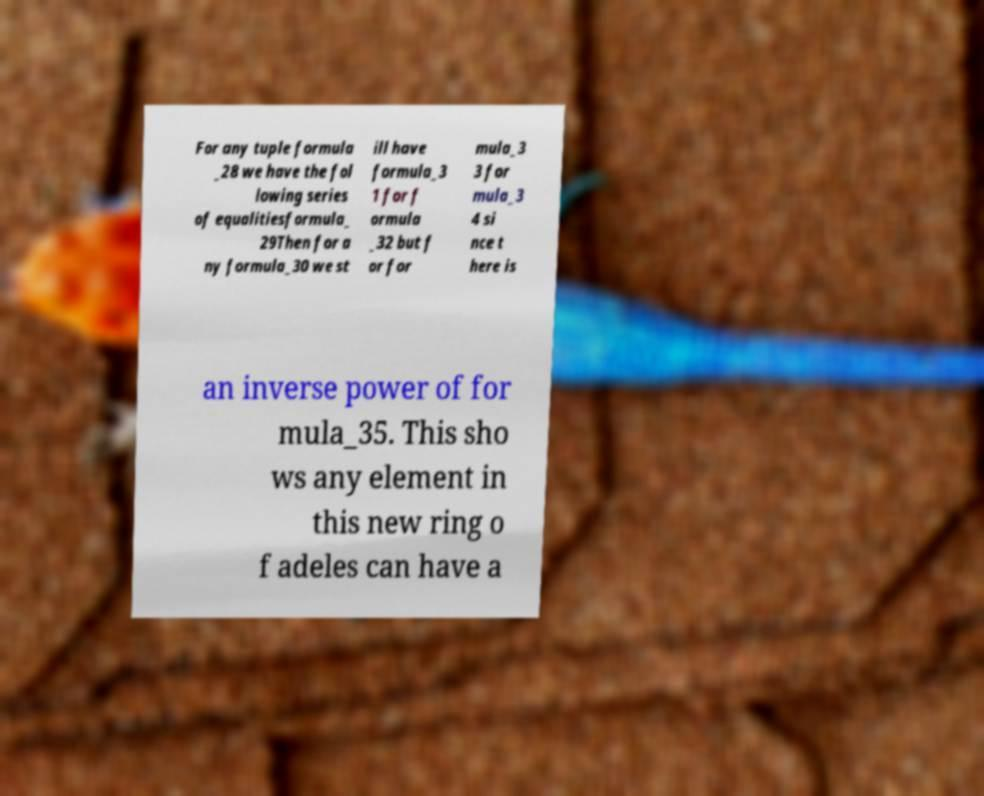For documentation purposes, I need the text within this image transcribed. Could you provide that? For any tuple formula _28 we have the fol lowing series of equalitiesformula_ 29Then for a ny formula_30 we st ill have formula_3 1 for f ormula _32 but f or for mula_3 3 for mula_3 4 si nce t here is an inverse power of for mula_35. This sho ws any element in this new ring o f adeles can have a 